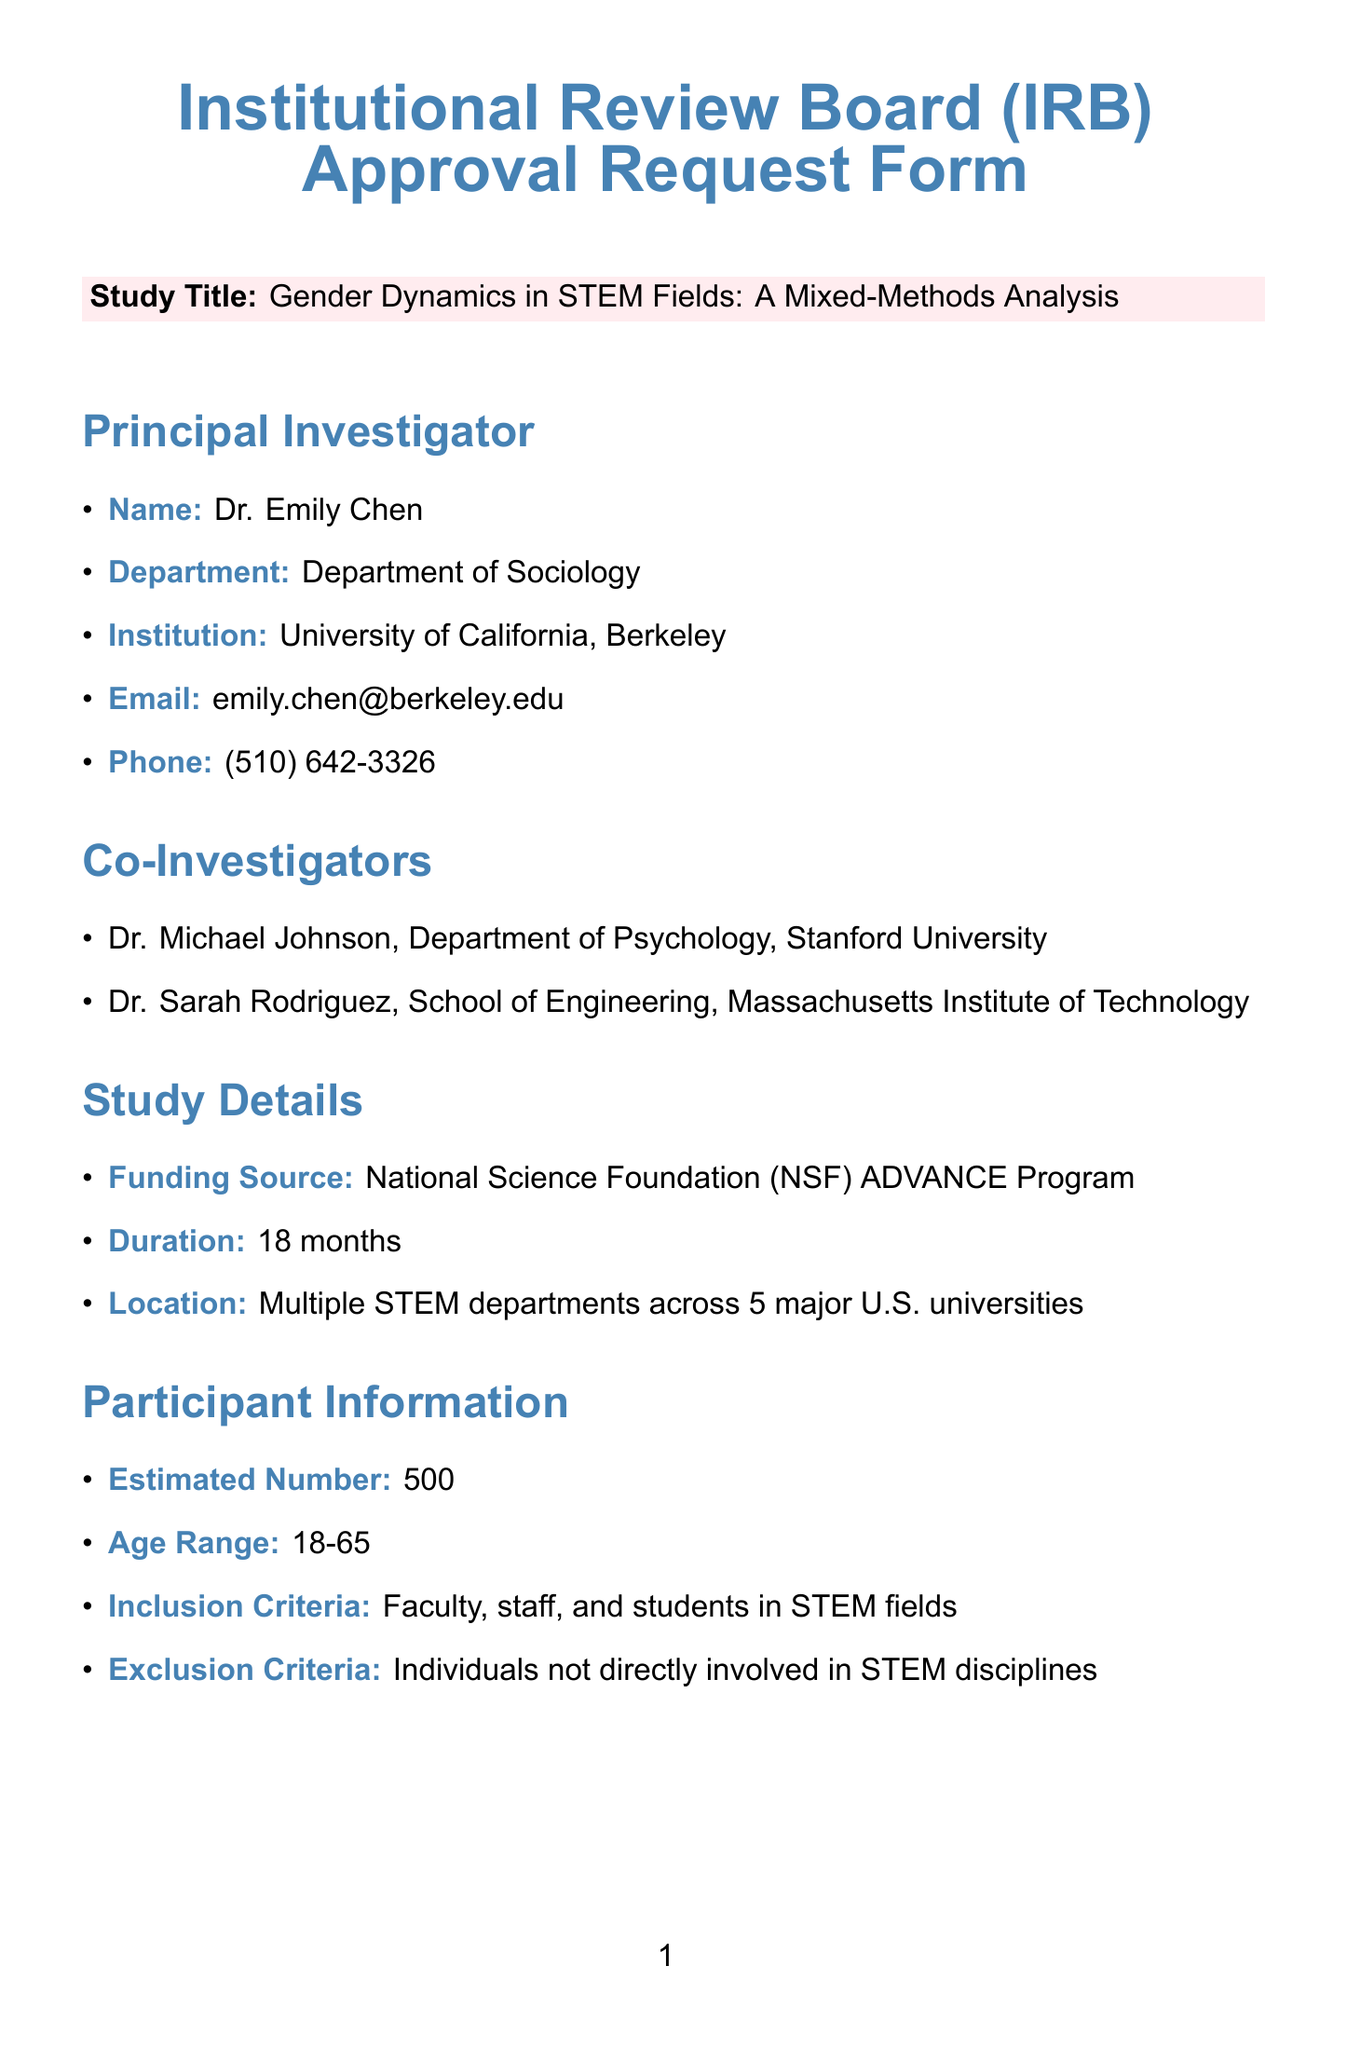What is the study title? The study title is directly stated in the document under study details, which is "Gender Dynamics in STEM Fields: A Mixed-Methods Analysis."
Answer: Gender Dynamics in STEM Fields: A Mixed-Methods Analysis Who is the principal investigator? The principal investigator's name is provided in the section dedicated to their details, which lists Dr. Emily Chen.
Answer: Dr. Emily Chen How many estimated participants will be involved in the study? The number of estimated participants is explicitly mentioned in the participant information section of the document.
Answer: 500 What is the funding source for the study? The funding source is indicated in the study details section, which mentions the National Science Foundation (NSF) ADVANCE Program.
Answer: National Science Foundation (NSF) ADVANCE Program What type of data collection methods will be used? The document lists the data collection methods in the methodology overview section, specifying multiple methods of gathering data.
Answer: Online surveys, Semi-structured interviews, Focus group discussions, Analysis of institutional data What is the age range of participants? The age range of participants is specified in the participant information section, stating the allowed ages for participation.
Answer: 18-65 What are the potential risks mentioned in the study? The potential risks are outlined in the risks and benefits section, highlighting possible psychological discomfort and confidentiality issues.
Answer: Minimal psychological discomfort, Potential for breach of confidentiality What is the retention period for stored data? The retention period for data storage is detailed in the data management plan section, indicating how long data will be kept after the study concludes.
Answer: 5 years post-study completion What method will be used for participant consent? The consent process section states that an electronic consent form will be used to obtain consent from participants.
Answer: Electronic consent form 